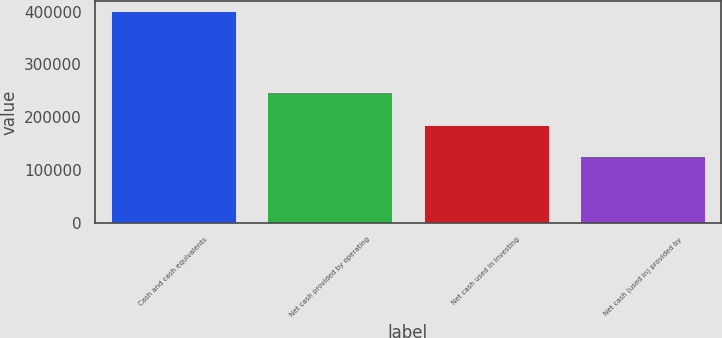Convert chart. <chart><loc_0><loc_0><loc_500><loc_500><bar_chart><fcel>Cash and cash equivalents<fcel>Net cash provided by operating<fcel>Net cash used in investing<fcel>Net cash (used in) provided by<nl><fcel>400430<fcel>248190<fcel>185869<fcel>125853<nl></chart> 